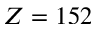Convert formula to latex. <formula><loc_0><loc_0><loc_500><loc_500>Z = 1 5 2</formula> 